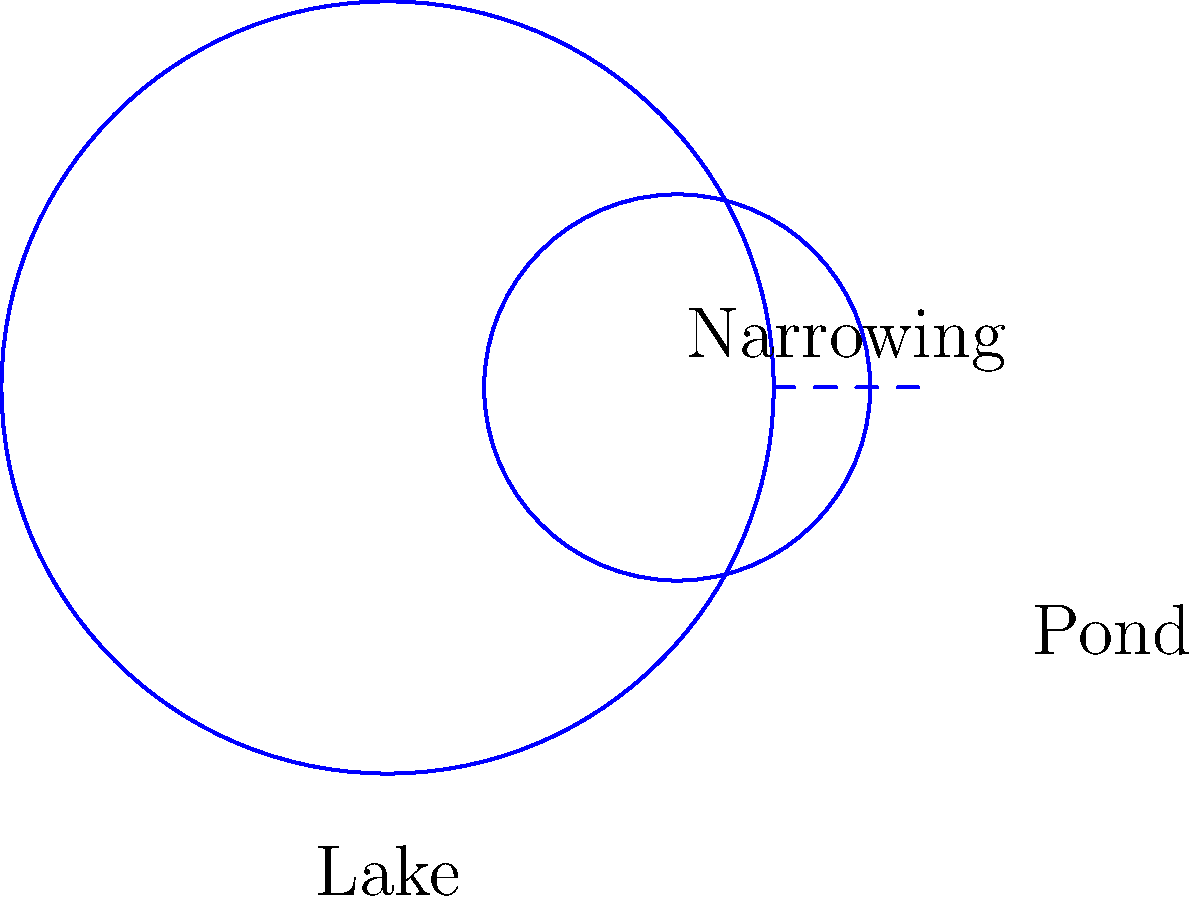Consider a landscape with a lake connected to a smaller pond by a narrow water channel, as shown in the diagram. From a topological perspective, are these two bodies of water homeomorphic? Justify your answer in the context of landscape painting and the preservation of peace in nature. To determine if the lake and pond are homeomorphic, we need to consider the following steps:

1. Definition of homeomorphism: Two topological spaces are homeomorphic if there exists a continuous bijective function between them with a continuous inverse.

2. Connectivity: Both the lake and pond are connected to each other through the narrow channel. This maintains their topological equivalence.

3. Deformation: Imagine the landscape as a flexible canvas. We can continuously deform the lake into the pond (or vice versa) without tearing or gluing, preserving their topological properties.

4. Boundaries: Both the lake and pond have single, continuous boundaries, which are preserved under the deformation.

5. Genus: Neither the lake nor the pond has any holes (aside from the water surface), so they have the same genus of 0.

6. Landscape painting perspective: As a landscape painter, you can represent this transformation by gradually blending the colors and shapes of the lake into the pond, symbolizing their topological equivalence.

7. Peace in nature: The homeomorphism between the lake and pond represents the harmonious connection in nature, reflecting the peace and continuity in the landscape.

Given these considerations, the lake and pond are indeed homeomorphic. This topological equivalence emphasizes the interconnectedness and peace in the natural landscape, aligning with the painter's values and background.
Answer: Yes, the lake and pond are homeomorphic. 